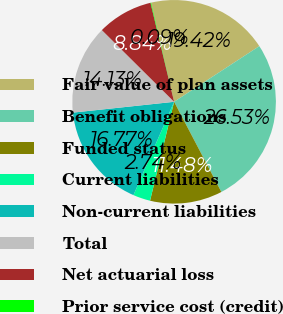<chart> <loc_0><loc_0><loc_500><loc_500><pie_chart><fcel>Fair value of plan assets<fcel>Benefit obligations<fcel>Funded status<fcel>Current liabilities<fcel>Non-current liabilities<fcel>Total<fcel>Net actuarial loss<fcel>Prior service cost (credit)<nl><fcel>19.42%<fcel>26.53%<fcel>11.48%<fcel>2.74%<fcel>16.77%<fcel>14.13%<fcel>8.84%<fcel>0.09%<nl></chart> 